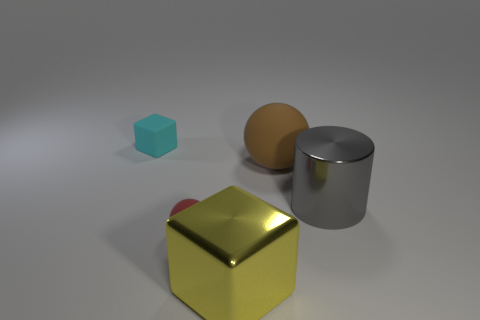What is the color of the large metal block?
Your response must be concise. Yellow. Is there anything else that is the same material as the big cylinder?
Your answer should be compact. Yes. What shape is the large metallic thing in front of the gray cylinder?
Keep it short and to the point. Cube. Are there any red things on the right side of the large yellow shiny cube that is on the right side of the matte ball that is in front of the big gray metallic cylinder?
Keep it short and to the point. No. Is there any other thing that is the same shape as the cyan object?
Give a very brief answer. Yes. Are there any big yellow matte objects?
Your answer should be very brief. No. Do the block behind the tiny red thing and the tiny object that is in front of the brown matte sphere have the same material?
Your answer should be very brief. Yes. What size is the object behind the sphere to the right of the tiny object in front of the small cyan matte thing?
Your response must be concise. Small. What number of other gray cylinders have the same material as the big gray cylinder?
Offer a terse response. 0. Is the number of brown shiny cylinders less than the number of tiny red objects?
Your response must be concise. Yes. 